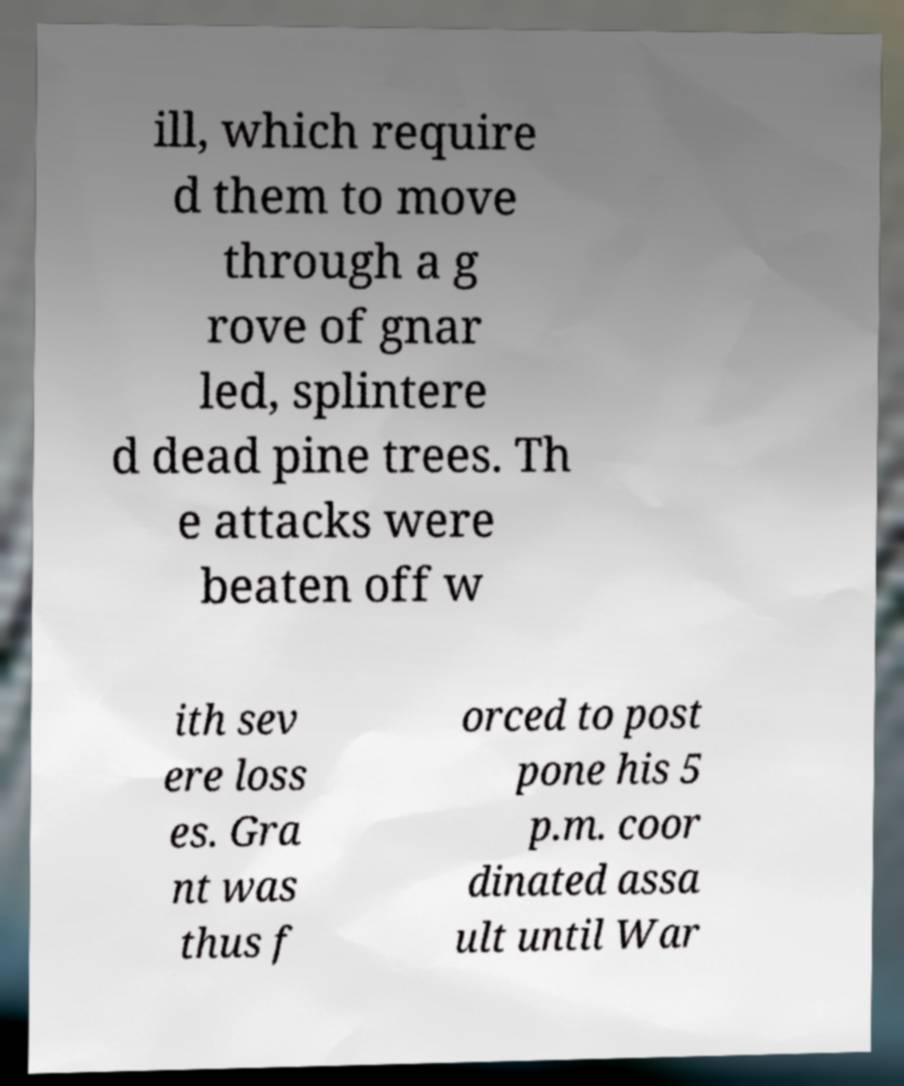Can you accurately transcribe the text from the provided image for me? ill, which require d them to move through a g rove of gnar led, splintere d dead pine trees. Th e attacks were beaten off w ith sev ere loss es. Gra nt was thus f orced to post pone his 5 p.m. coor dinated assa ult until War 